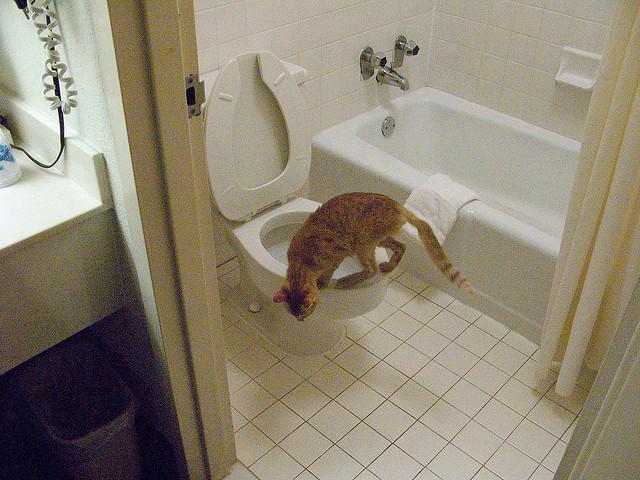Is this a hotel bathroom?
Answer briefly. Yes. Is the lid up?
Write a very short answer. Yes. Is there a cat on the toilet?
Concise answer only. Yes. 